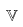<formula> <loc_0><loc_0><loc_500><loc_500>\mathbb { V }</formula> 